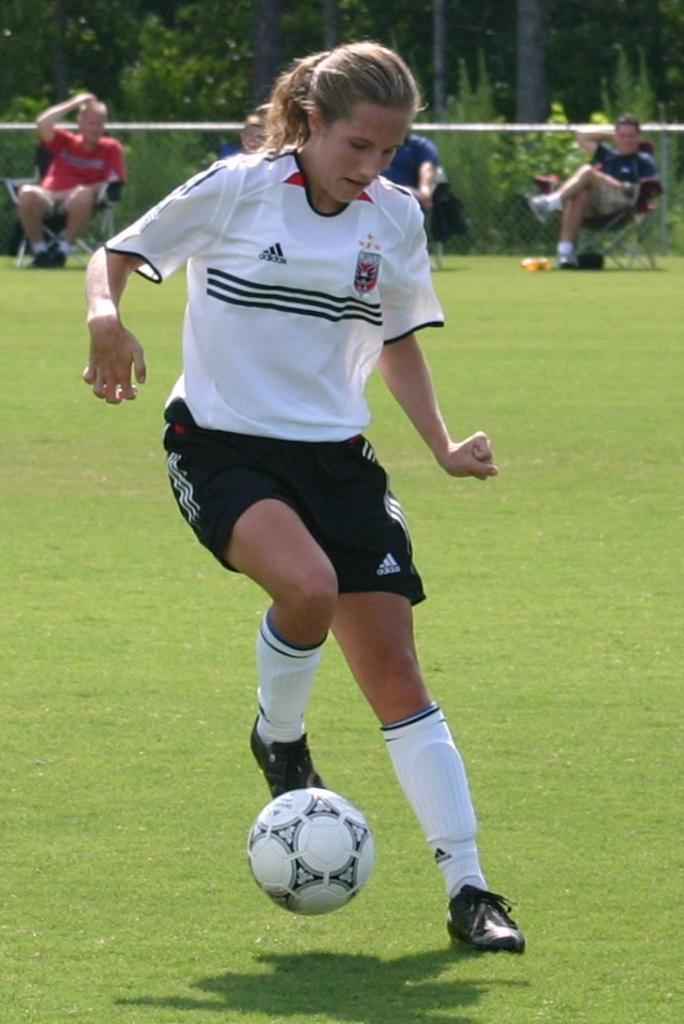What is the woman in the image doing? The woman is playing football in the image. Where is the woman located in the image? The woman is in the middle of the image. What can be seen in the background of the image? There are people sitting on chairs and trees visible in the background of the image. What type of knife is the woman using to play football in the image? There is no knife present in the image; the woman is playing football with a ball. 